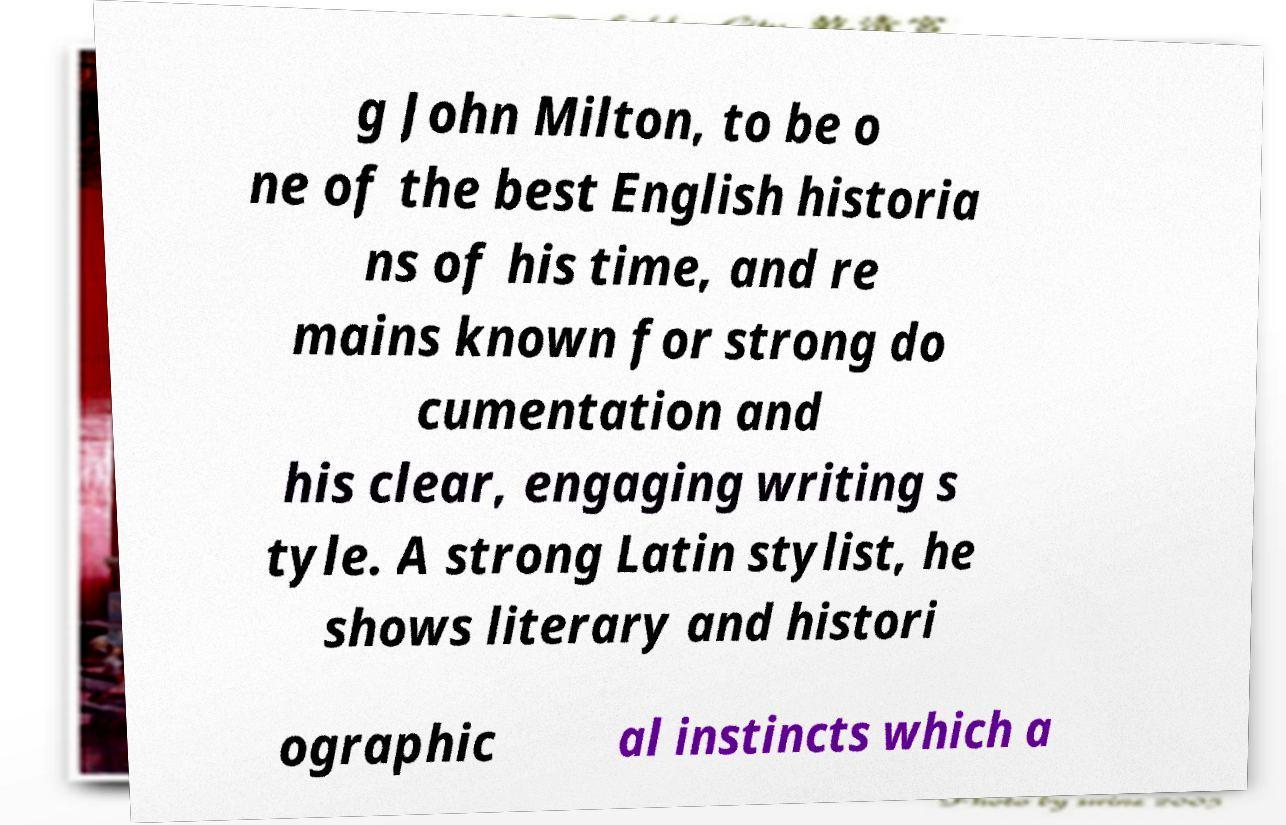Please read and relay the text visible in this image. What does it say? g John Milton, to be o ne of the best English historia ns of his time, and re mains known for strong do cumentation and his clear, engaging writing s tyle. A strong Latin stylist, he shows literary and histori ographic al instincts which a 